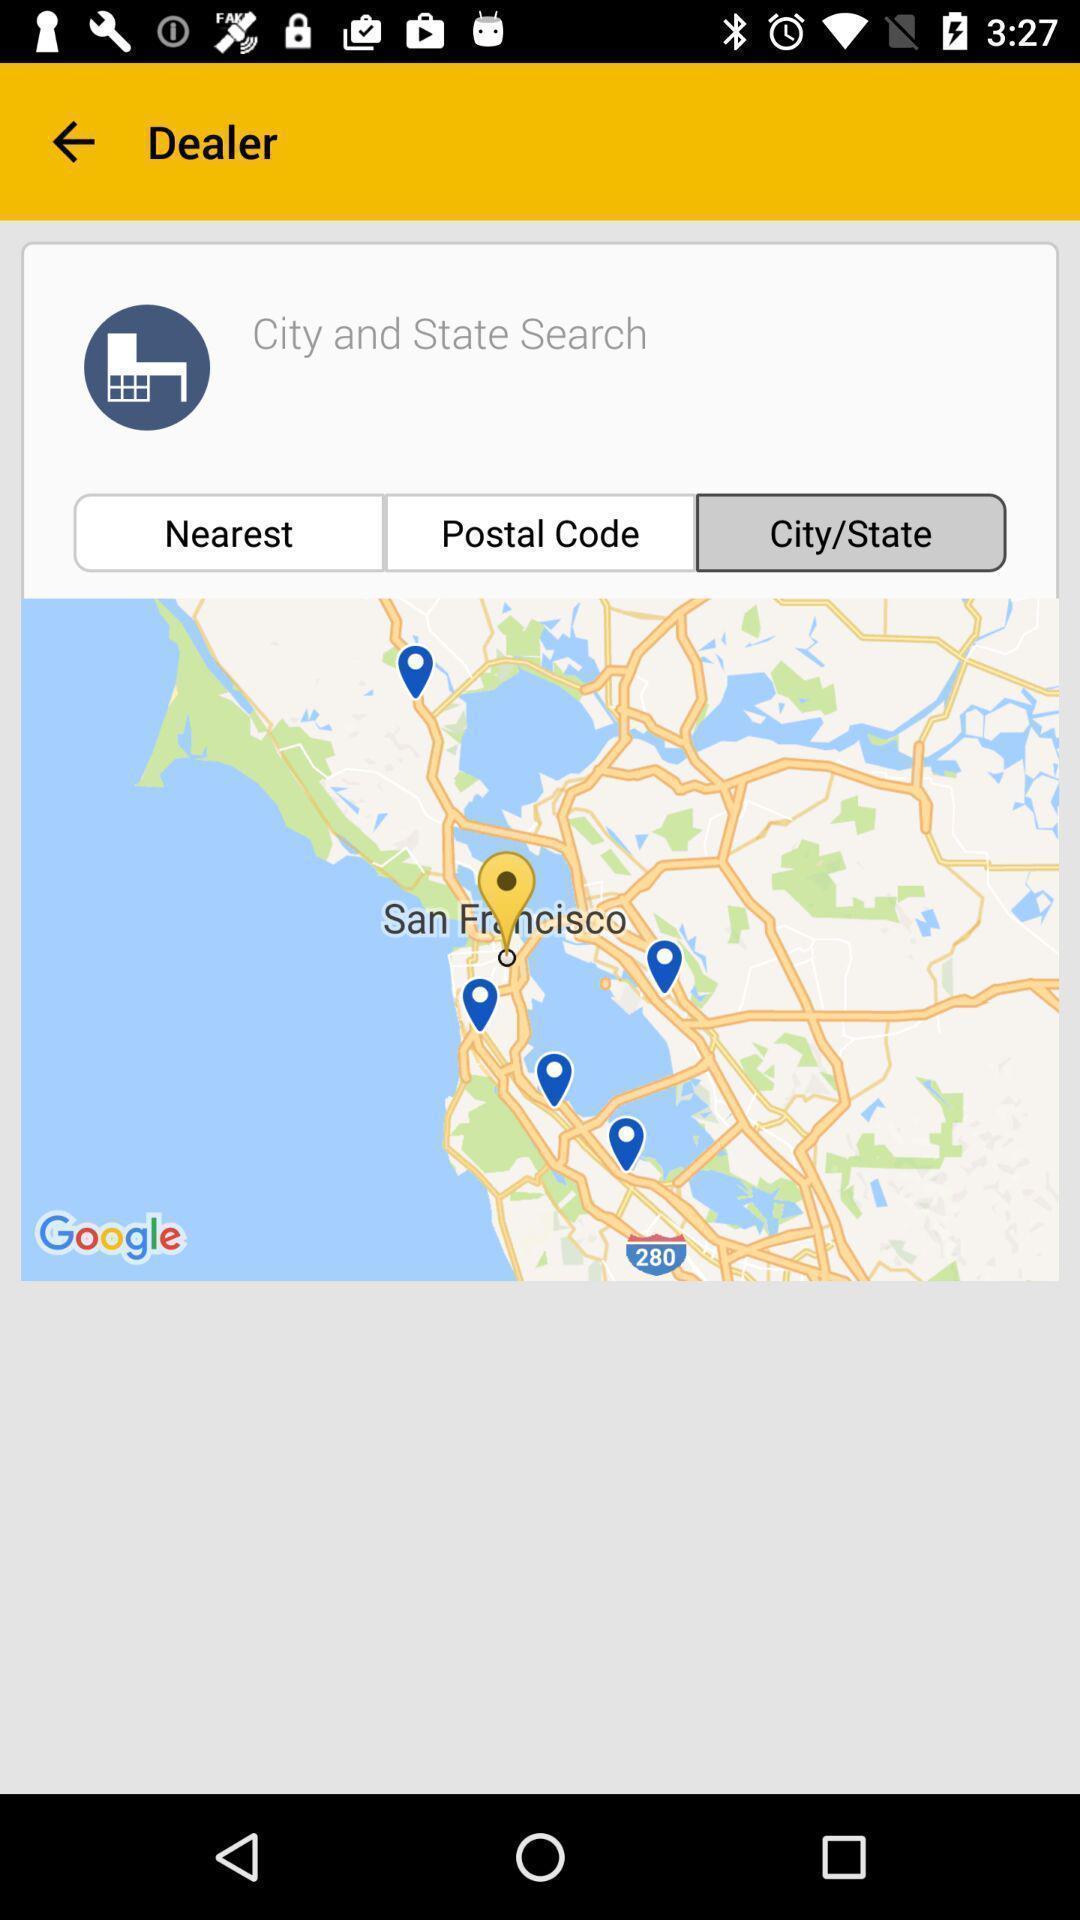Describe the visual elements of this screenshot. Screen shows dealer with search option in app. 